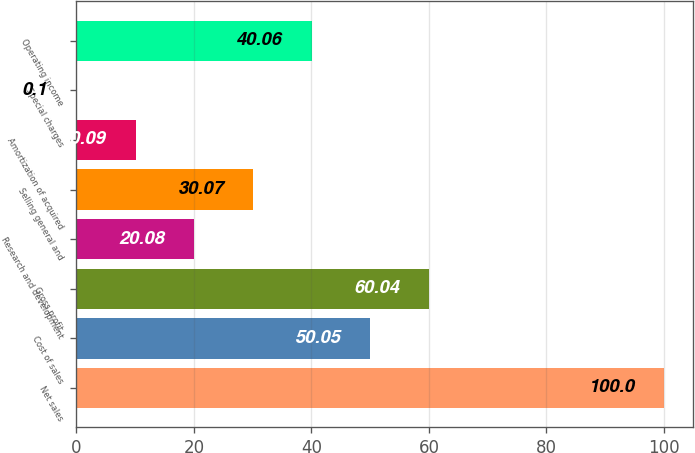Convert chart. <chart><loc_0><loc_0><loc_500><loc_500><bar_chart><fcel>Net sales<fcel>Cost of sales<fcel>Gross profit<fcel>Research and development<fcel>Selling general and<fcel>Amortization of acquired<fcel>Special charges<fcel>Operating income<nl><fcel>100<fcel>50.05<fcel>60.04<fcel>20.08<fcel>30.07<fcel>10.09<fcel>0.1<fcel>40.06<nl></chart> 